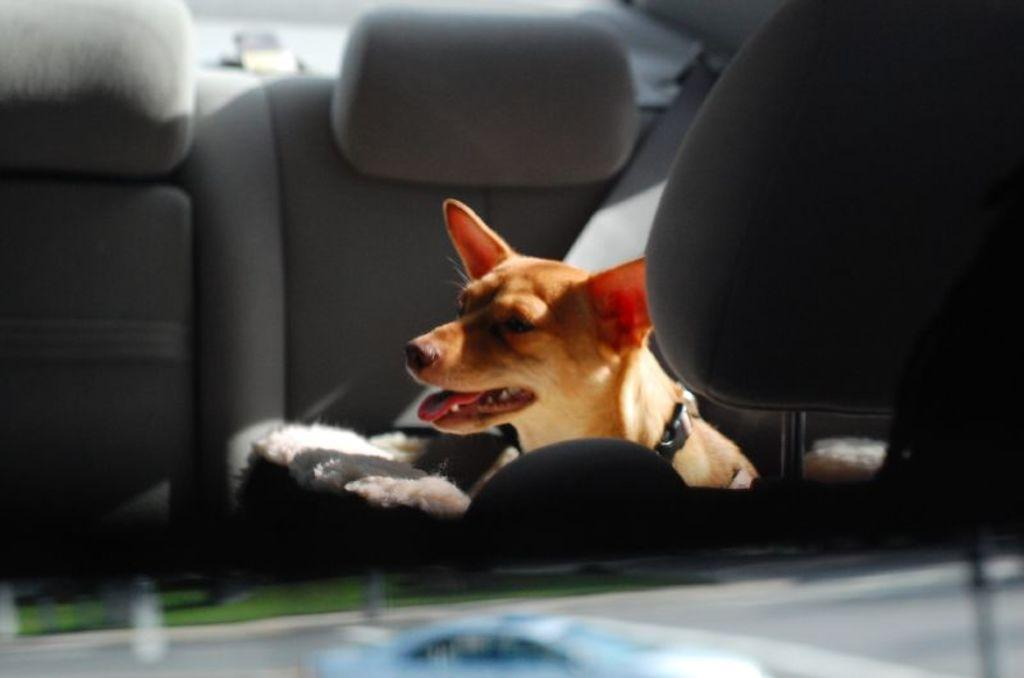What animal is present in the image? There is a dog in the image. Where is the dog located? The dog is in a car. How many plants are visible in the car with the dog? There are no plants visible in the car with the dog; the image only shows a dog in a car. 